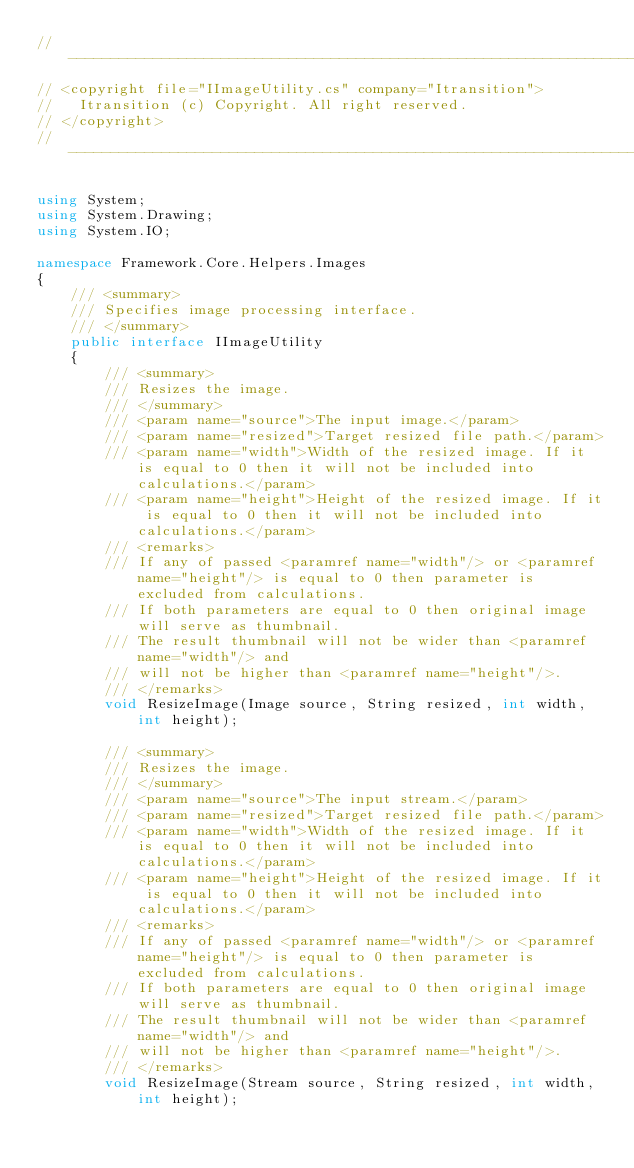Convert code to text. <code><loc_0><loc_0><loc_500><loc_500><_C#_>// --------------------------------------------------------------------------------------------------------------------
// <copyright file="IImageUtility.cs" company="Itransition">
//   Itransition (c) Copyright. All right reserved.
// </copyright>
// --------------------------------------------------------------------------------------------------------------------

using System;
using System.Drawing;
using System.IO;

namespace Framework.Core.Helpers.Images
{
    /// <summary>
    /// Specifies image processing interface.
    /// </summary>
    public interface IImageUtility
    {
        /// <summary>
        /// Resizes the image.
        /// </summary>
        /// <param name="source">The input image.</param>
        /// <param name="resized">Target resized file path.</param>
        /// <param name="width">Width of the resized image. If it is equal to 0 then it will not be included into calculations.</param>
        /// <param name="height">Height of the resized image. If it is equal to 0 then it will not be included into calculations.</param>
        /// <remarks>
        /// If any of passed <paramref name="width"/> or <paramref name="height"/> is equal to 0 then parameter is excluded from calculations.
        /// If both parameters are equal to 0 then original image will serve as thumbnail.
        /// The result thumbnail will not be wider than <paramref name="width"/> and
        /// will not be higher than <paramref name="height"/>.
        /// </remarks>
        void ResizeImage(Image source, String resized, int width, int height);

        /// <summary>
        /// Resizes the image.
        /// </summary>
        /// <param name="source">The input stream.</param>
        /// <param name="resized">Target resized file path.</param>
        /// <param name="width">Width of the resized image. If it is equal to 0 then it will not be included into calculations.</param>
        /// <param name="height">Height of the resized image. If it is equal to 0 then it will not be included into calculations.</param>
        /// <remarks>
        /// If any of passed <paramref name="width"/> or <paramref name="height"/> is equal to 0 then parameter is excluded from calculations.
        /// If both parameters are equal to 0 then original image will serve as thumbnail.
        /// The result thumbnail will not be wider than <paramref name="width"/> and
        /// will not be higher than <paramref name="height"/>.
        /// </remarks>
        void ResizeImage(Stream source, String resized, int width, int height);
</code> 